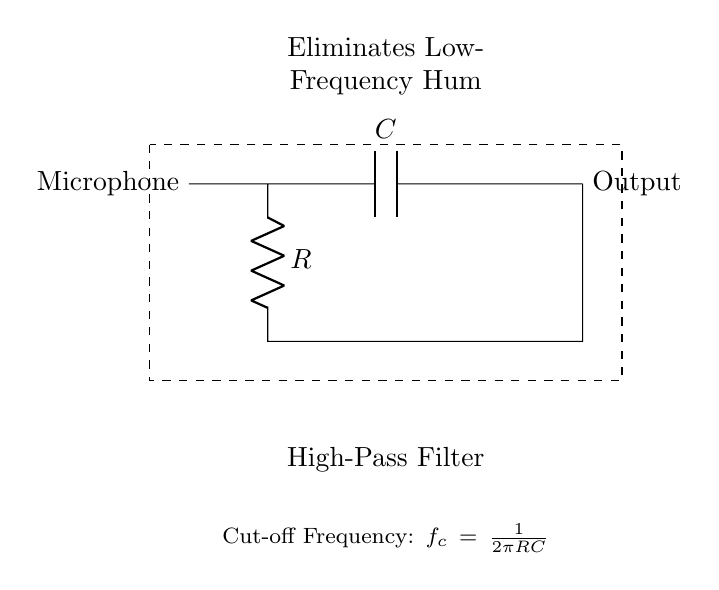What is the function of the capacitor in this circuit? The capacitor acts as a component that allows high-frequency signals to pass while blocking low-frequency signals, thus eliminating hum.
Answer: High-pass filter What is the value of the resistor labeled in the circuit? The resistance is denoted by R, which is a variable value that determines the cut-off frequency along with the capacitor.
Answer: R What is the role of the microphone in the circuit? The microphone serves as the input device that captures sound and converts it into an electrical signal for processing.
Answer: Input device What is the cut-off frequency formula for this high-pass filter? The cut-off frequency is calculated using the formula \( f_c = \frac{1}{2\pi RC} \), where R is the resistance and C is the capacitance.
Answer: One over two pi RC What type of filter is depicted in this circuit? The circuit is a type of filter designed to eliminate low-frequency noise while allowing higher frequencies to pass, specifically a high-pass filter.
Answer: High-pass filter What does the dashed rectangle represent in the circuit? The dashed rectangle visually groups the components and indicates that they collectively function as a high-pass filter.
Answer: High-pass filter enclosure 